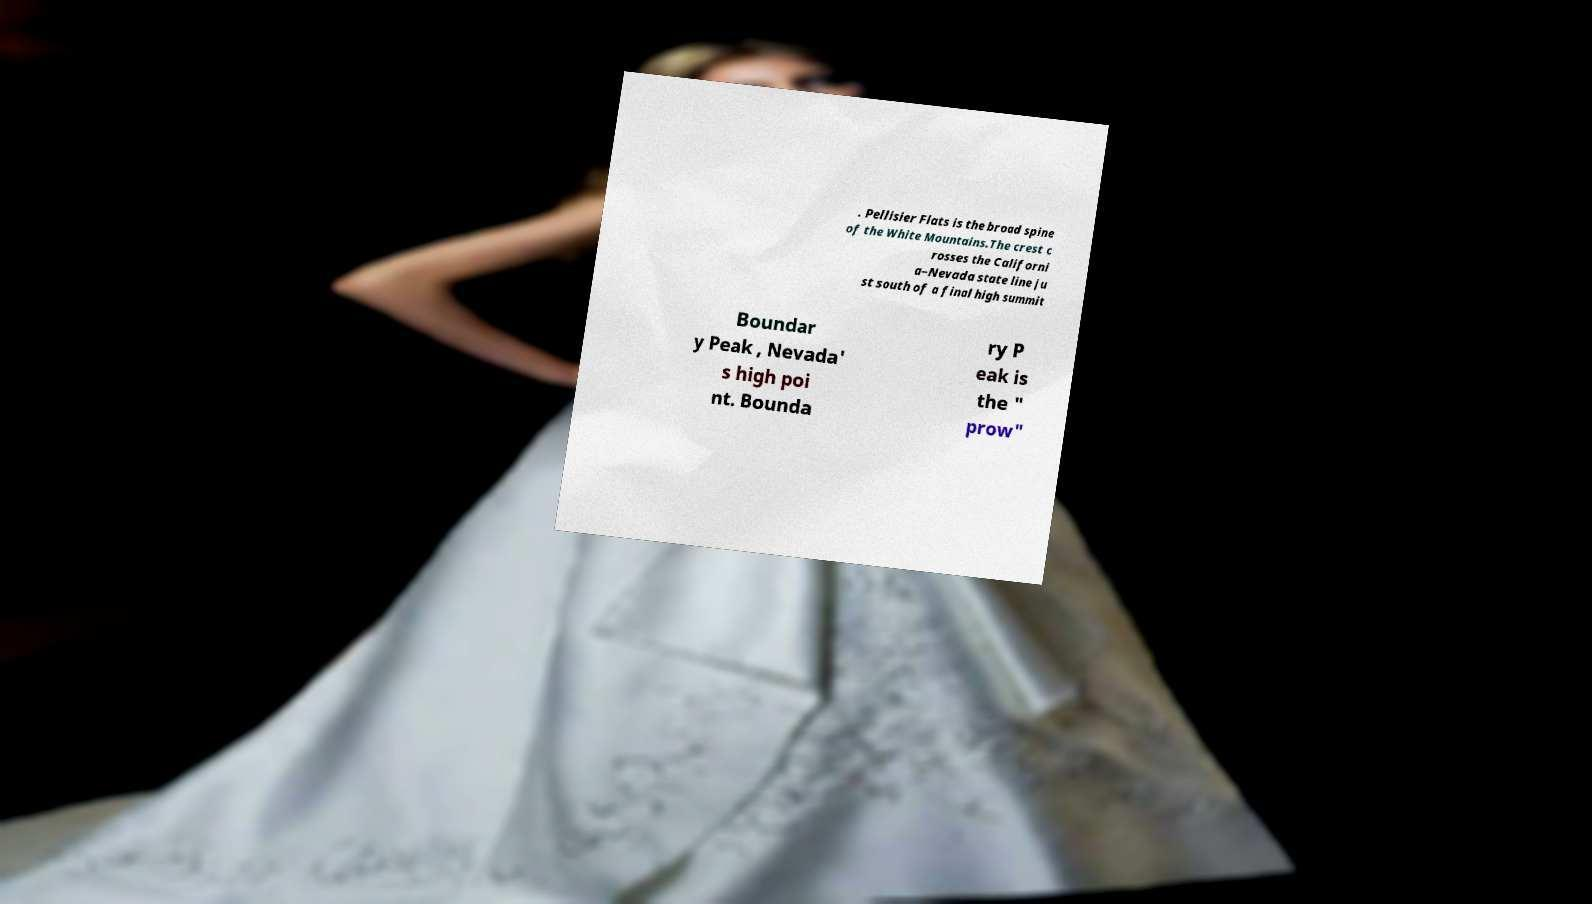Could you extract and type out the text from this image? . Pellisier Flats is the broad spine of the White Mountains.The crest c rosses the Californi a–Nevada state line ju st south of a final high summit Boundar y Peak , Nevada' s high poi nt. Bounda ry P eak is the " prow" 